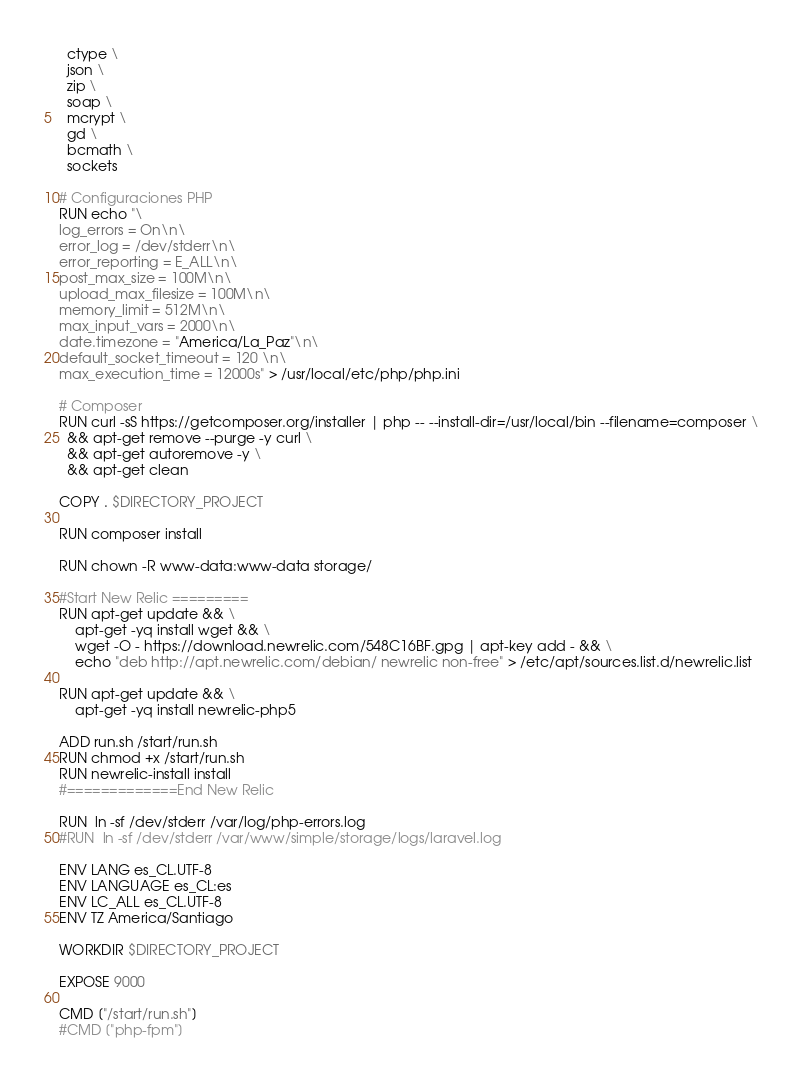Convert code to text. <code><loc_0><loc_0><loc_500><loc_500><_Dockerfile_>  ctype \
  json \
  zip \
  soap \
  mcrypt \
  gd \
  bcmath \
  sockets

# Configuraciones PHP
RUN echo "\
log_errors = On\n\
error_log = /dev/stderr\n\
error_reporting = E_ALL\n\
post_max_size = 100M\n\
upload_max_filesize = 100M\n\
memory_limit = 512M\n\
max_input_vars = 2000\n\
date.timezone = "America/La_Paz"\n\
default_socket_timeout = 120 \n\
max_execution_time = 12000s" > /usr/local/etc/php/php.ini

# Composer
RUN curl -sS https://getcomposer.org/installer | php -- --install-dir=/usr/local/bin --filename=composer \
  && apt-get remove --purge -y curl \
  && apt-get autoremove -y \
  && apt-get clean

COPY . $DIRECTORY_PROJECT

RUN composer install

RUN chown -R www-data:www-data storage/

#Start New Relic =========
RUN apt-get update && \
    apt-get -yq install wget && \
    wget -O - https://download.newrelic.com/548C16BF.gpg | apt-key add - && \
    echo "deb http://apt.newrelic.com/debian/ newrelic non-free" > /etc/apt/sources.list.d/newrelic.list
 
RUN apt-get update && \
    apt-get -yq install newrelic-php5
    
ADD run.sh /start/run.sh
RUN chmod +x /start/run.sh
RUN newrelic-install install
#=============End New Relic

RUN  ln -sf /dev/stderr /var/log/php-errors.log
#RUN  ln -sf /dev/stderr /var/www/simple/storage/logs/laravel.log

ENV LANG es_CL.UTF-8
ENV LANGUAGE es_CL:es
ENV LC_ALL es_CL.UTF-8
ENV TZ America/Santiago

WORKDIR $DIRECTORY_PROJECT

EXPOSE 9000

CMD ["/start/run.sh"]
#CMD ["php-fpm"]</code> 